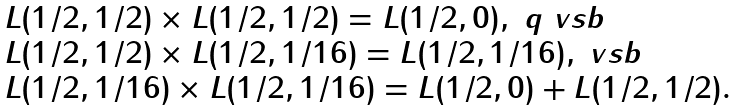<formula> <loc_0><loc_0><loc_500><loc_500>\begin{array} { l } L ( 1 / 2 , 1 / 2 ) \times L ( 1 / 2 , 1 / 2 ) = L ( 1 / 2 , 0 ) , \ q \ v s b \\ L ( 1 / 2 , 1 / 2 ) \times L ( 1 / 2 , 1 / 1 6 ) = L ( 1 / 2 , 1 / 1 6 ) , \ v s b \\ L ( 1 / 2 , 1 / 1 6 ) \times L ( 1 / 2 , 1 / 1 6 ) = L ( 1 / 2 , 0 ) + L ( 1 / 2 , 1 / 2 ) . \end{array}</formula> 